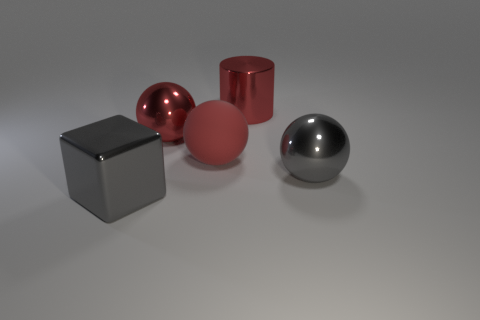Add 1 spheres. How many objects exist? 6 Subtract all cylinders. How many objects are left? 4 Subtract 0 brown cubes. How many objects are left? 5 Subtract all small purple matte objects. Subtract all red metal things. How many objects are left? 3 Add 4 balls. How many balls are left? 7 Add 2 gray blocks. How many gray blocks exist? 3 